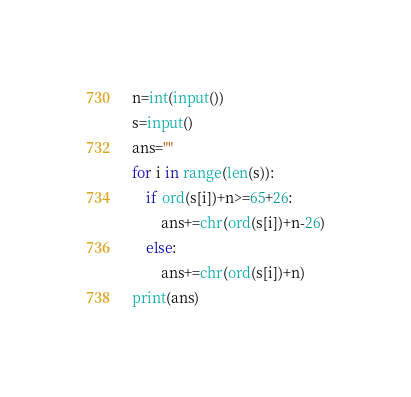<code> <loc_0><loc_0><loc_500><loc_500><_Python_>n=int(input())
s=input()
ans=""
for i in range(len(s)):
    if ord(s[i])+n>=65+26:
        ans+=chr(ord(s[i])+n-26)
    else:
        ans+=chr(ord(s[i])+n)
print(ans)</code> 